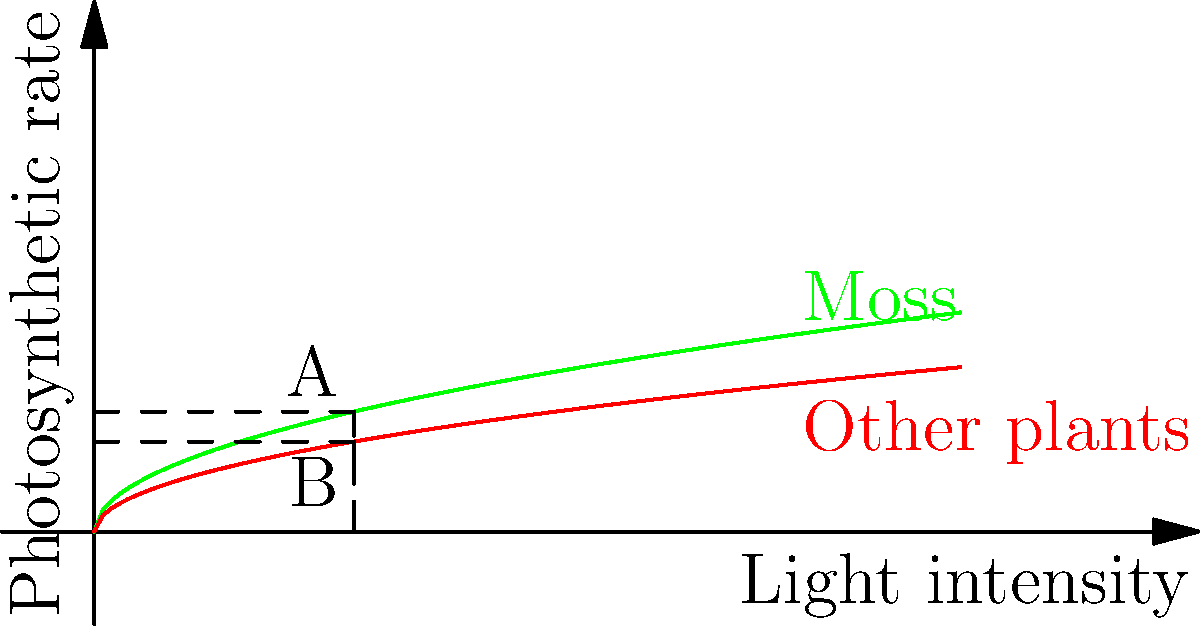Betrachte die Grafik, die die Photosyntheserate von Moos im Vergleich zu anderen Pflanzen in Abhängigkeit von der Lichtintensität zeigt. Bei einer bestimmten Lichtintensität (markiert durch die gestrichelte Linie) hat Moos eine Photosyntheserate von A, während andere Pflanzen eine Rate von B haben. Berechne das Verhältnis der Photosyntheseeffizienz von Moos zu anderen Pflanzen (A/B) und erkläre, warum Moos effizienter sein könnte. 1. Die Grafik zeigt, dass Moos bei gleicher Lichtintensität eine höhere Photosyntheserate aufweist als andere Pflanzen.

2. Bei der markierten Lichtintensität:
   - Moos hat eine Photosyntheserate von A
   - Andere Pflanzen haben eine Rate von B

3. Das Verhältnis der Effizienz wird berechnet durch: $\frac{A}{B}$

4. Aus der Grafik können wir ablesen:
   A ≈ 1.4
   B ≈ 1.0

5. Das Verhältnis ist somit: $\frac{A}{B} = \frac{1.4}{1.0} = 1.4$

6. Moos ist also etwa 40% effizienter in der Photosynthese als andere Pflanzen.

7. Gründe für die höhere Effizienz von Moos:
   a) Anpassung an schattige Habitate: Moose wachsen oft in lichtarmen Umgebungen und haben effizientere Chloroplastenanordnungen entwickelt.
   b) Einfachere Struktur: Moose haben keine komplexen Gewebestrukturen wie Gefäßpflanzen, was den Energieaufwand für Wachstum und Erhaltung reduziert.
   c) Direkte CO2-Aufnahme: Moose können CO2 direkt über ihre Oberfläche aufnehmen, was den Prozess effizienter macht.
   d) Spezielle Pigmente: Moose könnten zusätzliche Pigmente haben, die ein breiteres Lichtspektrum nutzen.
Answer: Moos ist ca. 40% effizienter (Verhältnis 1.4) aufgrund von Anpassungen an schattige Habitate, einfacherer Struktur, direkter CO2-Aufnahme und möglicherweise speziellen Pigmenten. 